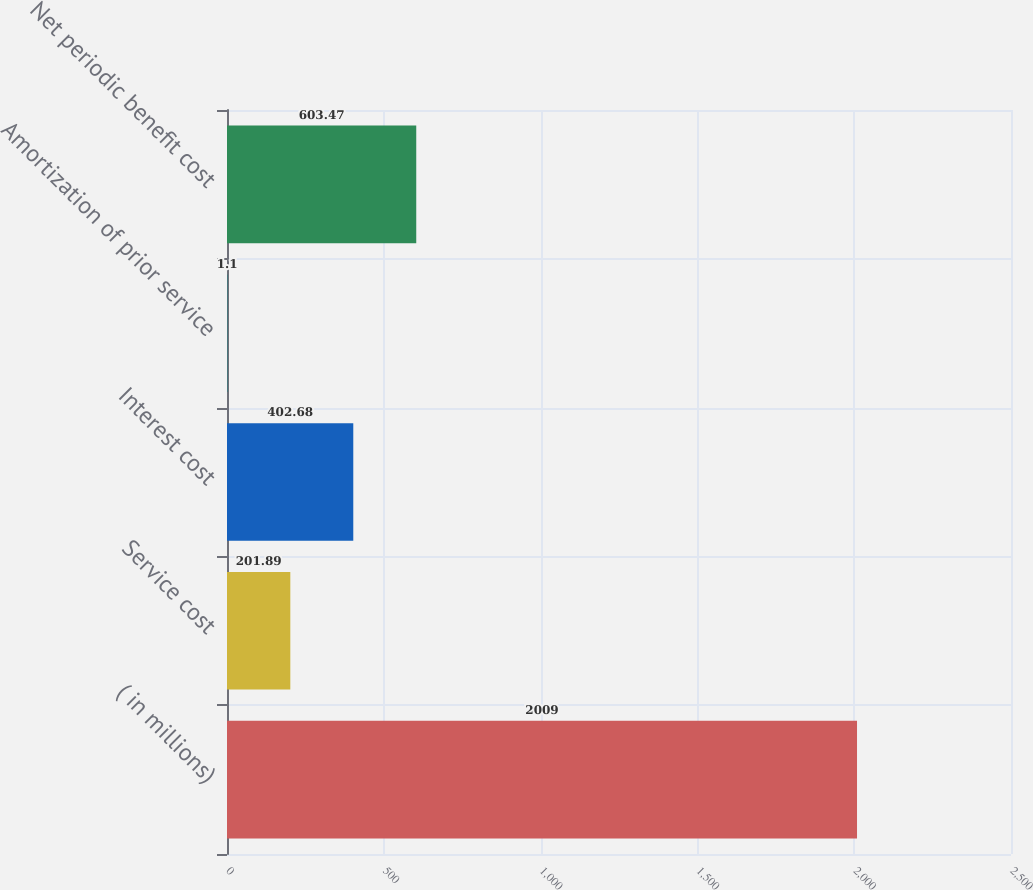<chart> <loc_0><loc_0><loc_500><loc_500><bar_chart><fcel>( in millions)<fcel>Service cost<fcel>Interest cost<fcel>Amortization of prior service<fcel>Net periodic benefit cost<nl><fcel>2009<fcel>201.89<fcel>402.68<fcel>1.1<fcel>603.47<nl></chart> 